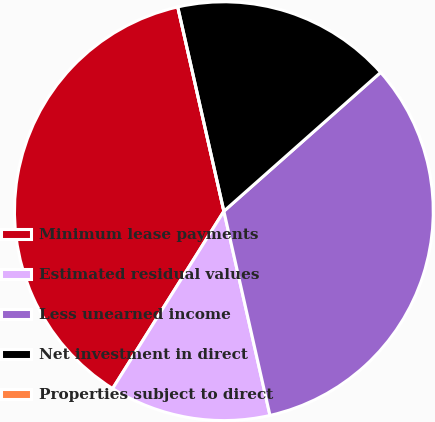<chart> <loc_0><loc_0><loc_500><loc_500><pie_chart><fcel>Minimum lease payments<fcel>Estimated residual values<fcel>Less unearned income<fcel>Net investment in direct<fcel>Properties subject to direct<nl><fcel>37.55%<fcel>12.45%<fcel>33.0%<fcel>17.0%<fcel>0.0%<nl></chart> 